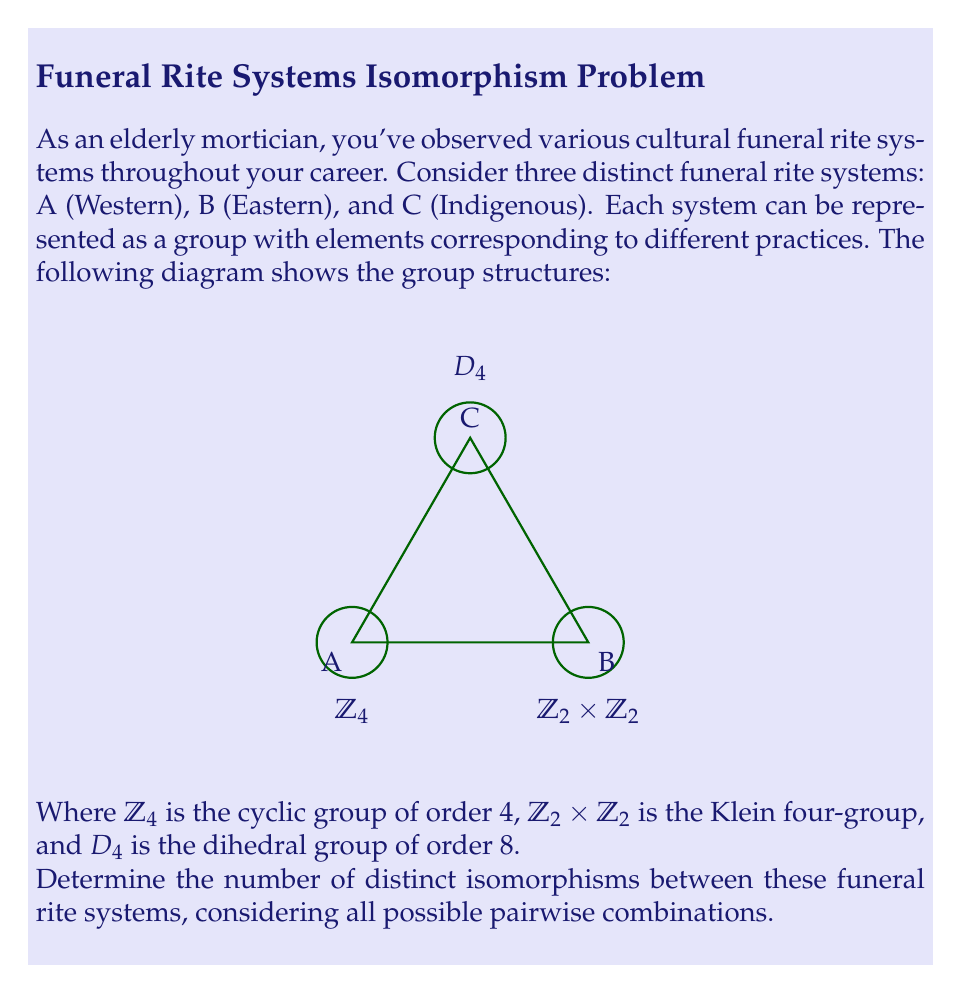Give your solution to this math problem. Let's approach this step-by-step:

1) First, we need to understand what isomorphisms are possible between these groups:

   a) $\mathbb{Z}_4 \cong \mathbb{Z}_4$
   b) $\mathbb{Z}_2 \times \mathbb{Z}_2 \cong \mathbb{Z}_2 \times \mathbb{Z}_2$
   c) $D_4 \cong D_4$

   Note that $\mathbb{Z}_4 \not\cong \mathbb{Z}_2 \times \mathbb{Z}_2$ because $\mathbb{Z}_4$ has an element of order 4, while $\mathbb{Z}_2 \times \mathbb{Z}_2$ does not.

2) Now, let's count the automorphisms for each group:

   a) $\mathbb{Z}_4$ has $\phi(4) = 2$ automorphisms
   b) $\mathbb{Z}_2 \times \mathbb{Z}_2$ has $|GL(2,\mathbb{Z}_2)| = 6$ automorphisms
   c) $D_4$ has 8 automorphisms

3) For each pair of systems, we count:

   A to A: 2 isomorphisms
   B to B: 6 isomorphisms
   C to C: 8 isomorphisms
   A to B: 0 isomorphisms
   A to C: 0 isomorphisms
   B to C: 0 isomorphisms

4) The total number of distinct isomorphisms is the sum of all these:

   $2 + 6 + 8 + 0 + 0 + 0 = 16$

Therefore, there are 16 distinct isomorphisms between these funeral rite systems.
Answer: 16 